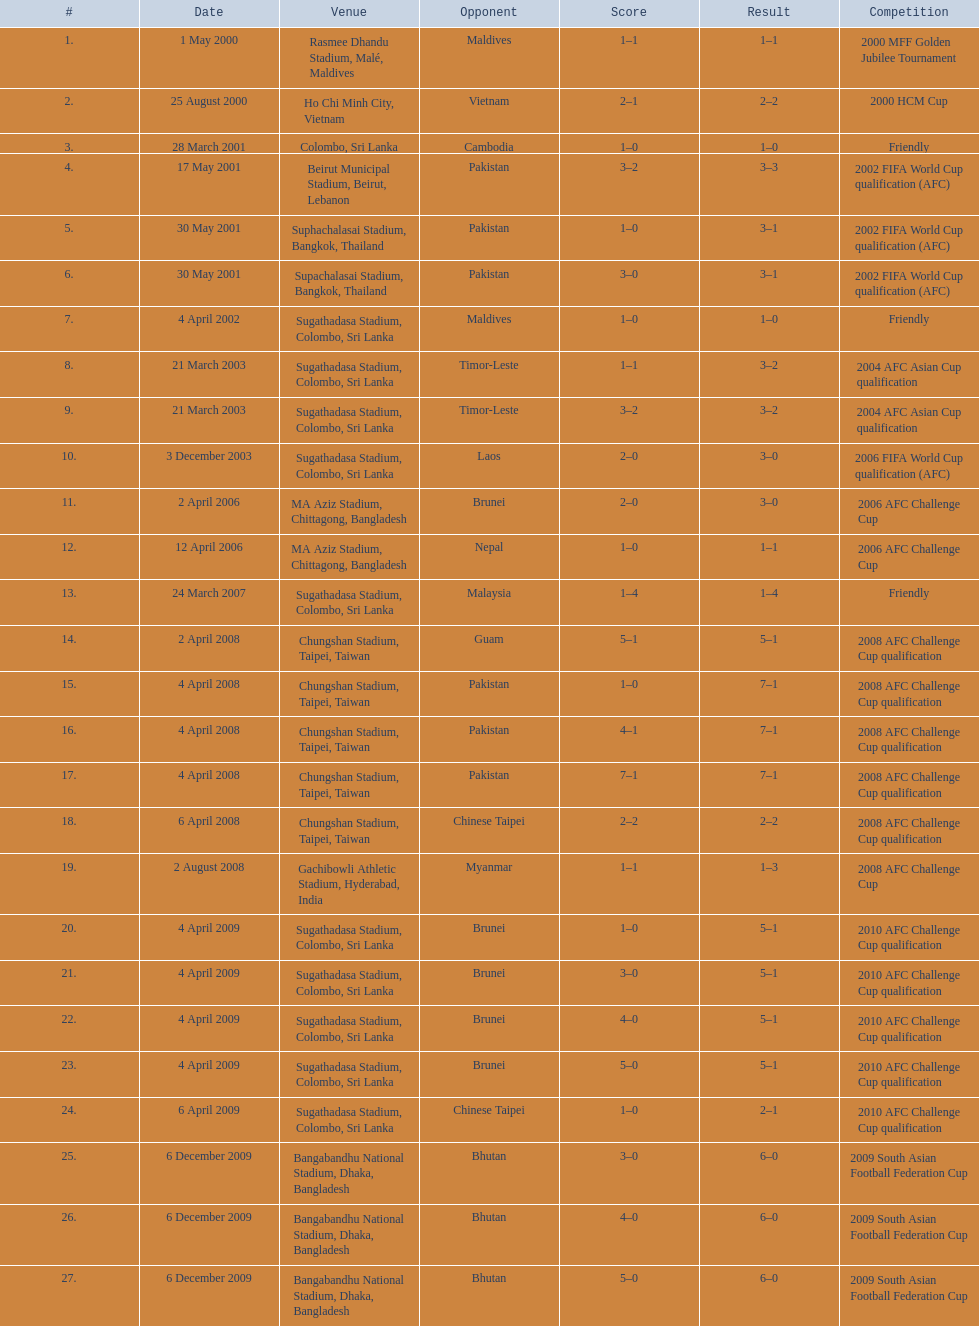How many times was laos the opponent? 1. 